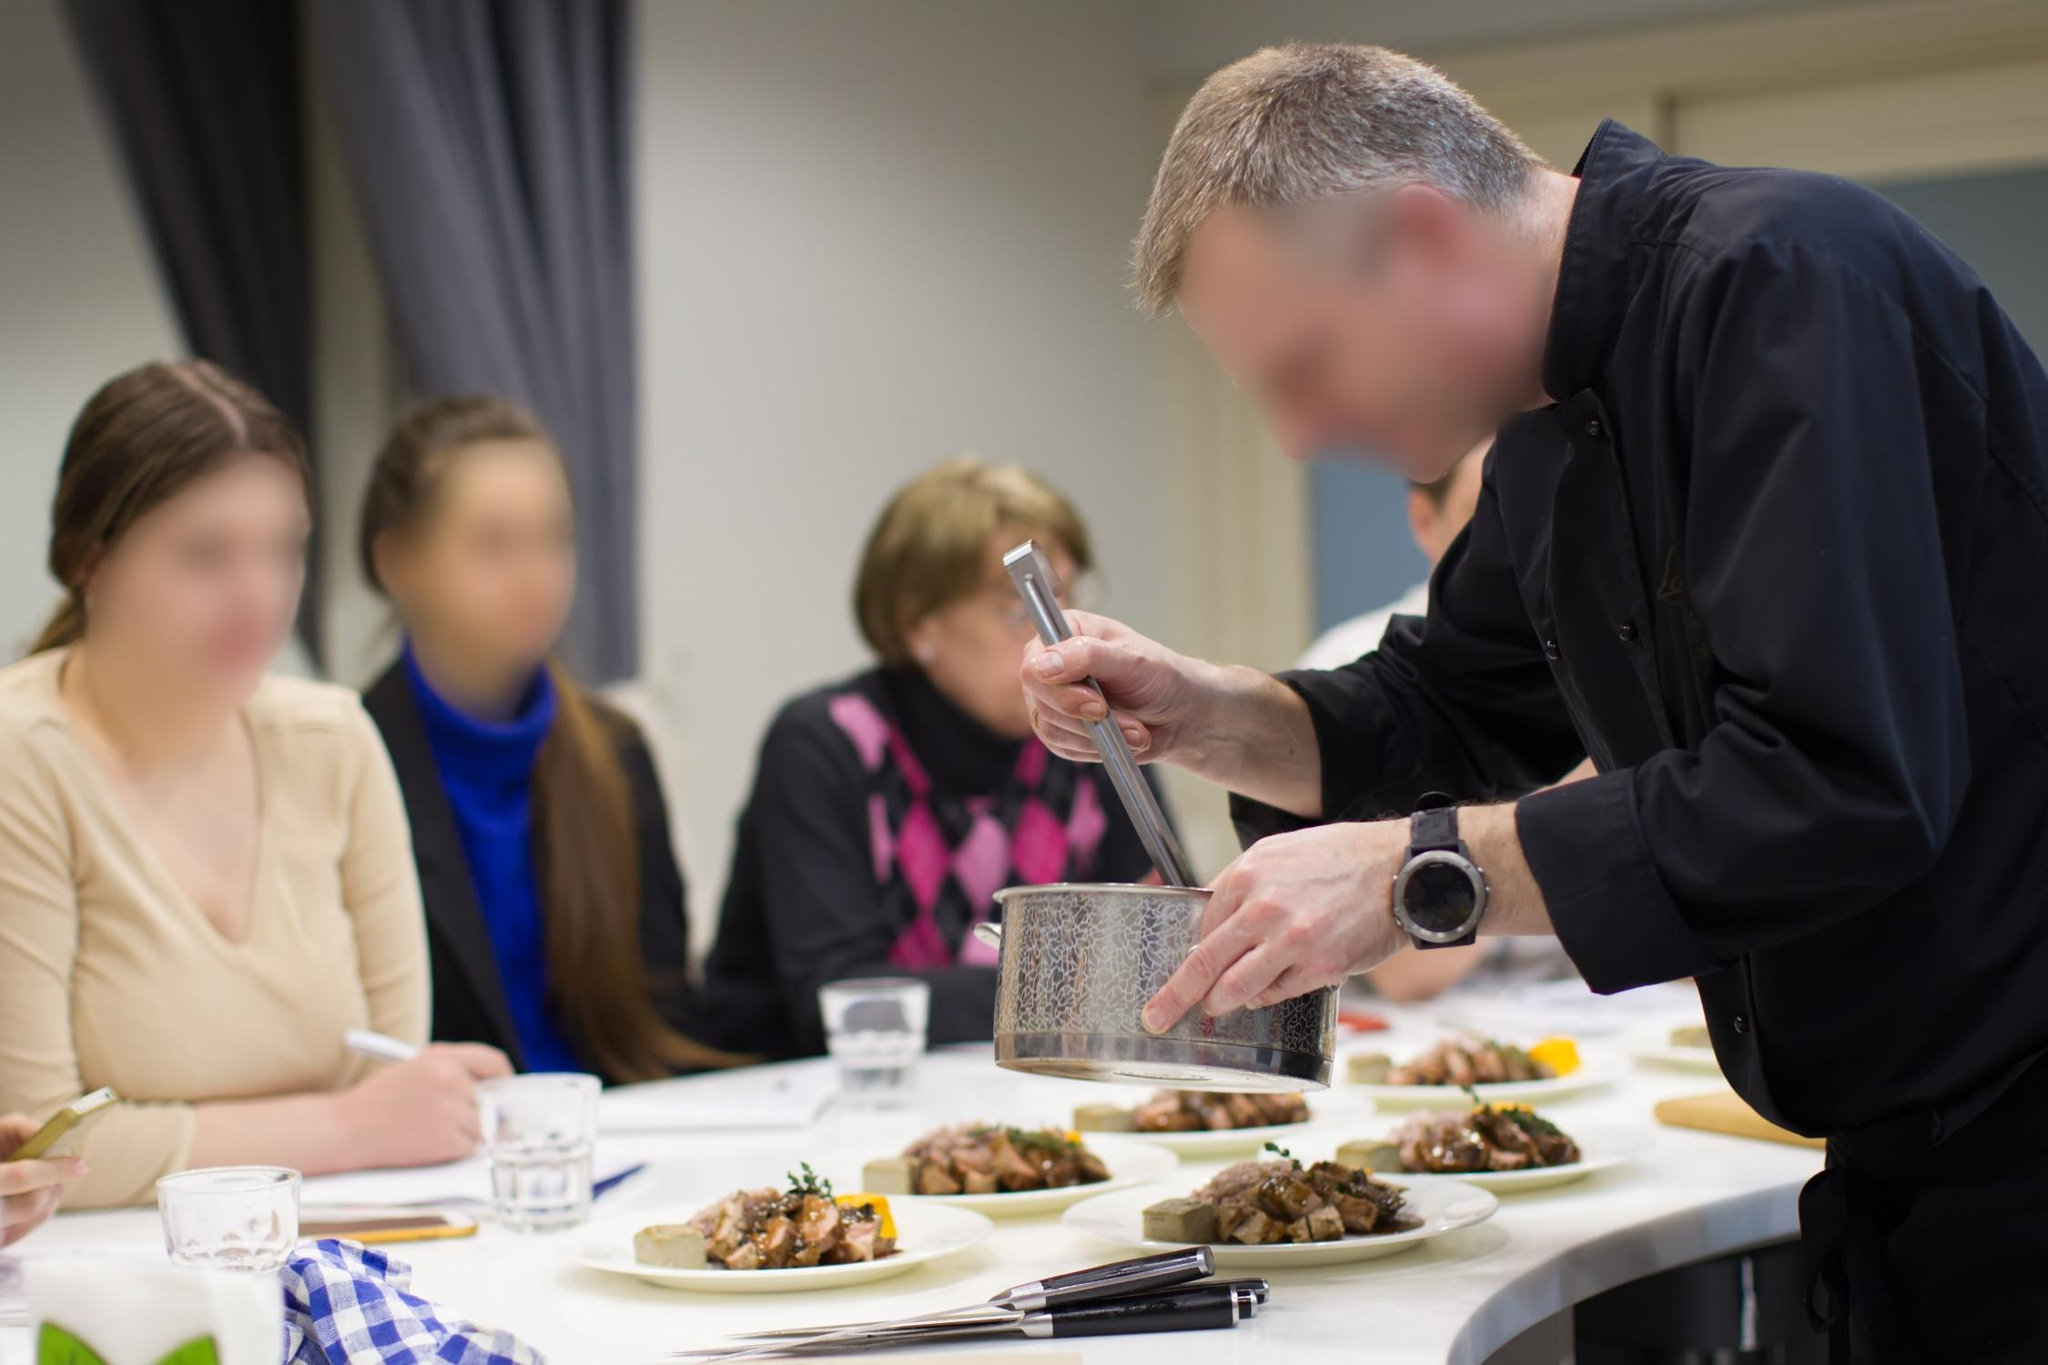Describe a potential realistic scenario for the spectators' experience during this cooking demo. The spectators enrolled in the cooking demo as part of a gourmet cooking workshop held at a renowned culinary school. Each of them is passionate about cooking and eager to enhance their skills under the guidance of Chef Alistair, a respected figure in the culinary world. Throughout the session, they take notes, ask insightful questions, and taste the chef's creations, gaining hands-on experience that they can replicate in their home kitchens. This practical learning environment allows them to grasp professional techniques and tips, enriching their culinary repertoire and confidence. 